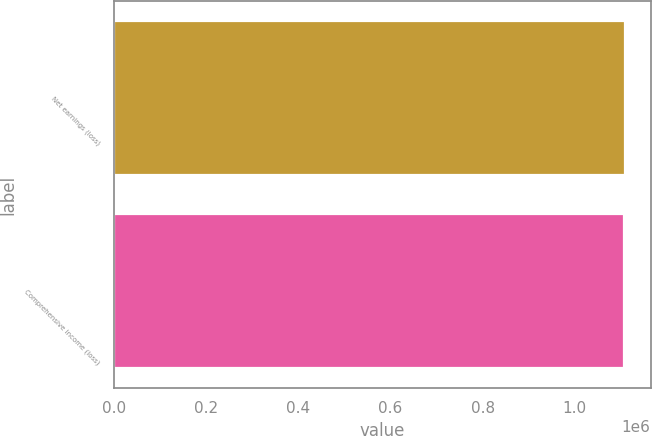Convert chart to OTSL. <chart><loc_0><loc_0><loc_500><loc_500><bar_chart><fcel>Net earnings (loss)<fcel>Comprehensive income (loss)<nl><fcel>1.10908e+06<fcel>1.10702e+06<nl></chart> 